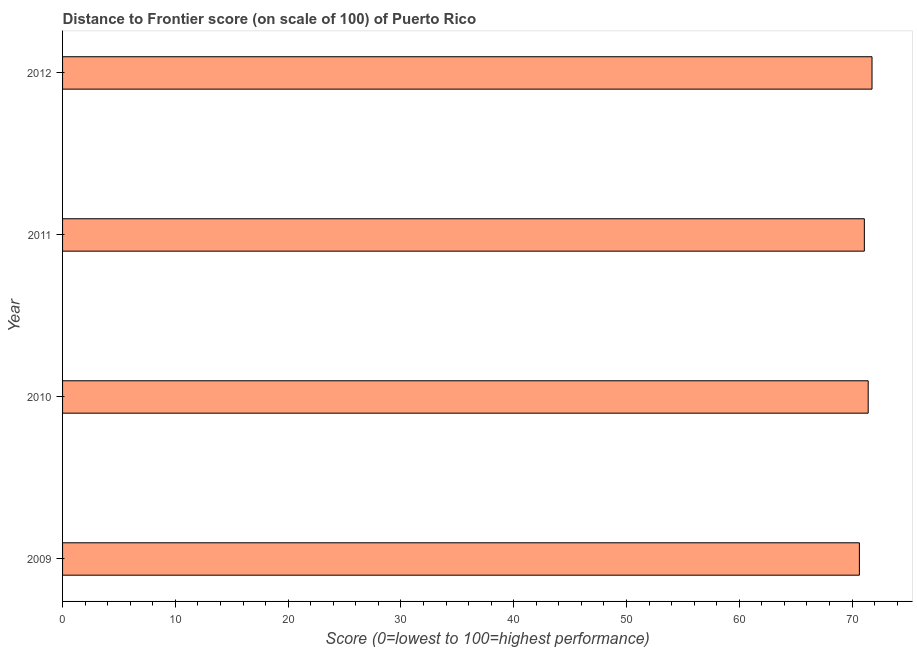Does the graph contain any zero values?
Provide a short and direct response. No. What is the title of the graph?
Your answer should be very brief. Distance to Frontier score (on scale of 100) of Puerto Rico. What is the label or title of the X-axis?
Keep it short and to the point. Score (0=lowest to 100=highest performance). What is the distance to frontier score in 2012?
Offer a very short reply. 71.77. Across all years, what is the maximum distance to frontier score?
Provide a succinct answer. 71.77. Across all years, what is the minimum distance to frontier score?
Offer a very short reply. 70.65. What is the sum of the distance to frontier score?
Ensure brevity in your answer.  284.94. What is the difference between the distance to frontier score in 2009 and 2010?
Ensure brevity in your answer.  -0.78. What is the average distance to frontier score per year?
Your answer should be very brief. 71.23. What is the median distance to frontier score?
Ensure brevity in your answer.  71.26. In how many years, is the distance to frontier score greater than 62 ?
Provide a succinct answer. 4. What is the ratio of the distance to frontier score in 2010 to that in 2012?
Provide a succinct answer. 0.99. What is the difference between the highest and the second highest distance to frontier score?
Offer a very short reply. 0.34. Is the sum of the distance to frontier score in 2011 and 2012 greater than the maximum distance to frontier score across all years?
Your response must be concise. Yes. What is the difference between the highest and the lowest distance to frontier score?
Offer a very short reply. 1.12. How many bars are there?
Offer a terse response. 4. Are all the bars in the graph horizontal?
Your answer should be very brief. Yes. How many years are there in the graph?
Your answer should be compact. 4. What is the difference between two consecutive major ticks on the X-axis?
Your answer should be compact. 10. What is the Score (0=lowest to 100=highest performance) in 2009?
Provide a short and direct response. 70.65. What is the Score (0=lowest to 100=highest performance) of 2010?
Make the answer very short. 71.43. What is the Score (0=lowest to 100=highest performance) in 2011?
Your answer should be very brief. 71.09. What is the Score (0=lowest to 100=highest performance) in 2012?
Provide a short and direct response. 71.77. What is the difference between the Score (0=lowest to 100=highest performance) in 2009 and 2010?
Provide a short and direct response. -0.78. What is the difference between the Score (0=lowest to 100=highest performance) in 2009 and 2011?
Provide a succinct answer. -0.44. What is the difference between the Score (0=lowest to 100=highest performance) in 2009 and 2012?
Your answer should be compact. -1.12. What is the difference between the Score (0=lowest to 100=highest performance) in 2010 and 2011?
Your answer should be compact. 0.34. What is the difference between the Score (0=lowest to 100=highest performance) in 2010 and 2012?
Make the answer very short. -0.34. What is the difference between the Score (0=lowest to 100=highest performance) in 2011 and 2012?
Your answer should be compact. -0.68. What is the ratio of the Score (0=lowest to 100=highest performance) in 2009 to that in 2010?
Your answer should be very brief. 0.99. What is the ratio of the Score (0=lowest to 100=highest performance) in 2009 to that in 2011?
Make the answer very short. 0.99. What is the ratio of the Score (0=lowest to 100=highest performance) in 2009 to that in 2012?
Ensure brevity in your answer.  0.98. What is the ratio of the Score (0=lowest to 100=highest performance) in 2010 to that in 2011?
Your answer should be very brief. 1. What is the ratio of the Score (0=lowest to 100=highest performance) in 2010 to that in 2012?
Give a very brief answer. 0.99. 